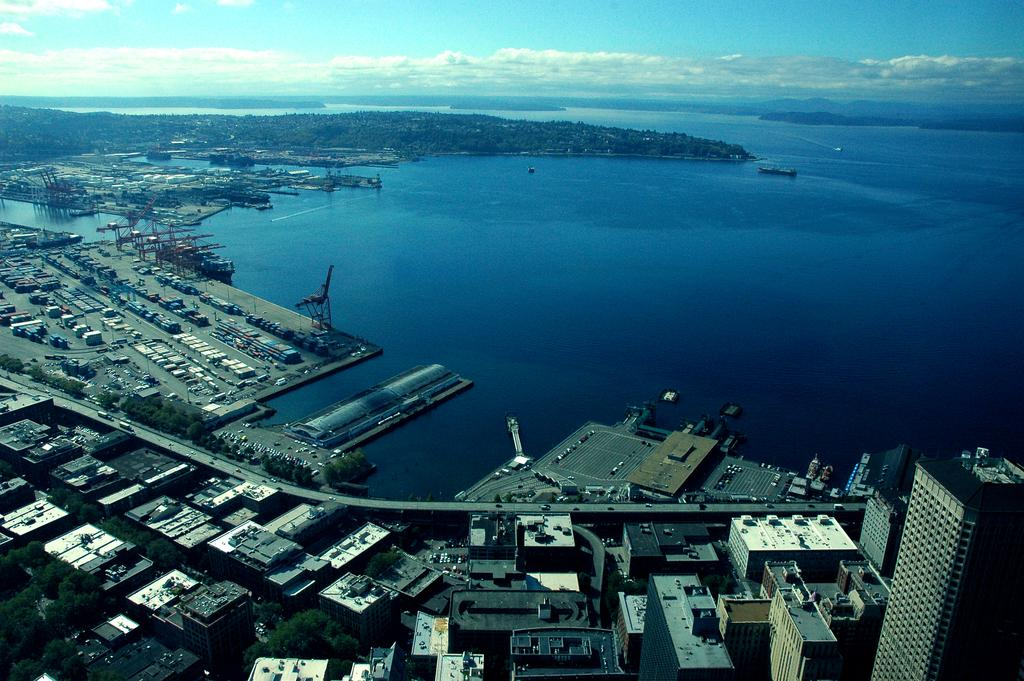What is the perspective of the image? The image is taken from a top angle. What structures can be seen in the image? There are multiple buildings in the image. What type of transportation is present in the image? There are vehicles in the image. What natural feature is visible in the image? There is a river in the image. What type of vegetation is present in the image? There are trees in the image. What is visible in the background of the image? The sky is visible in the image. How many chickens are swimming in the river in the image? There are no chickens present in the image, and therefore no such activity can be observed. What type of boats are docked along the river in the image? There are no boats present in the image; it features a river, but no boats are visible. 